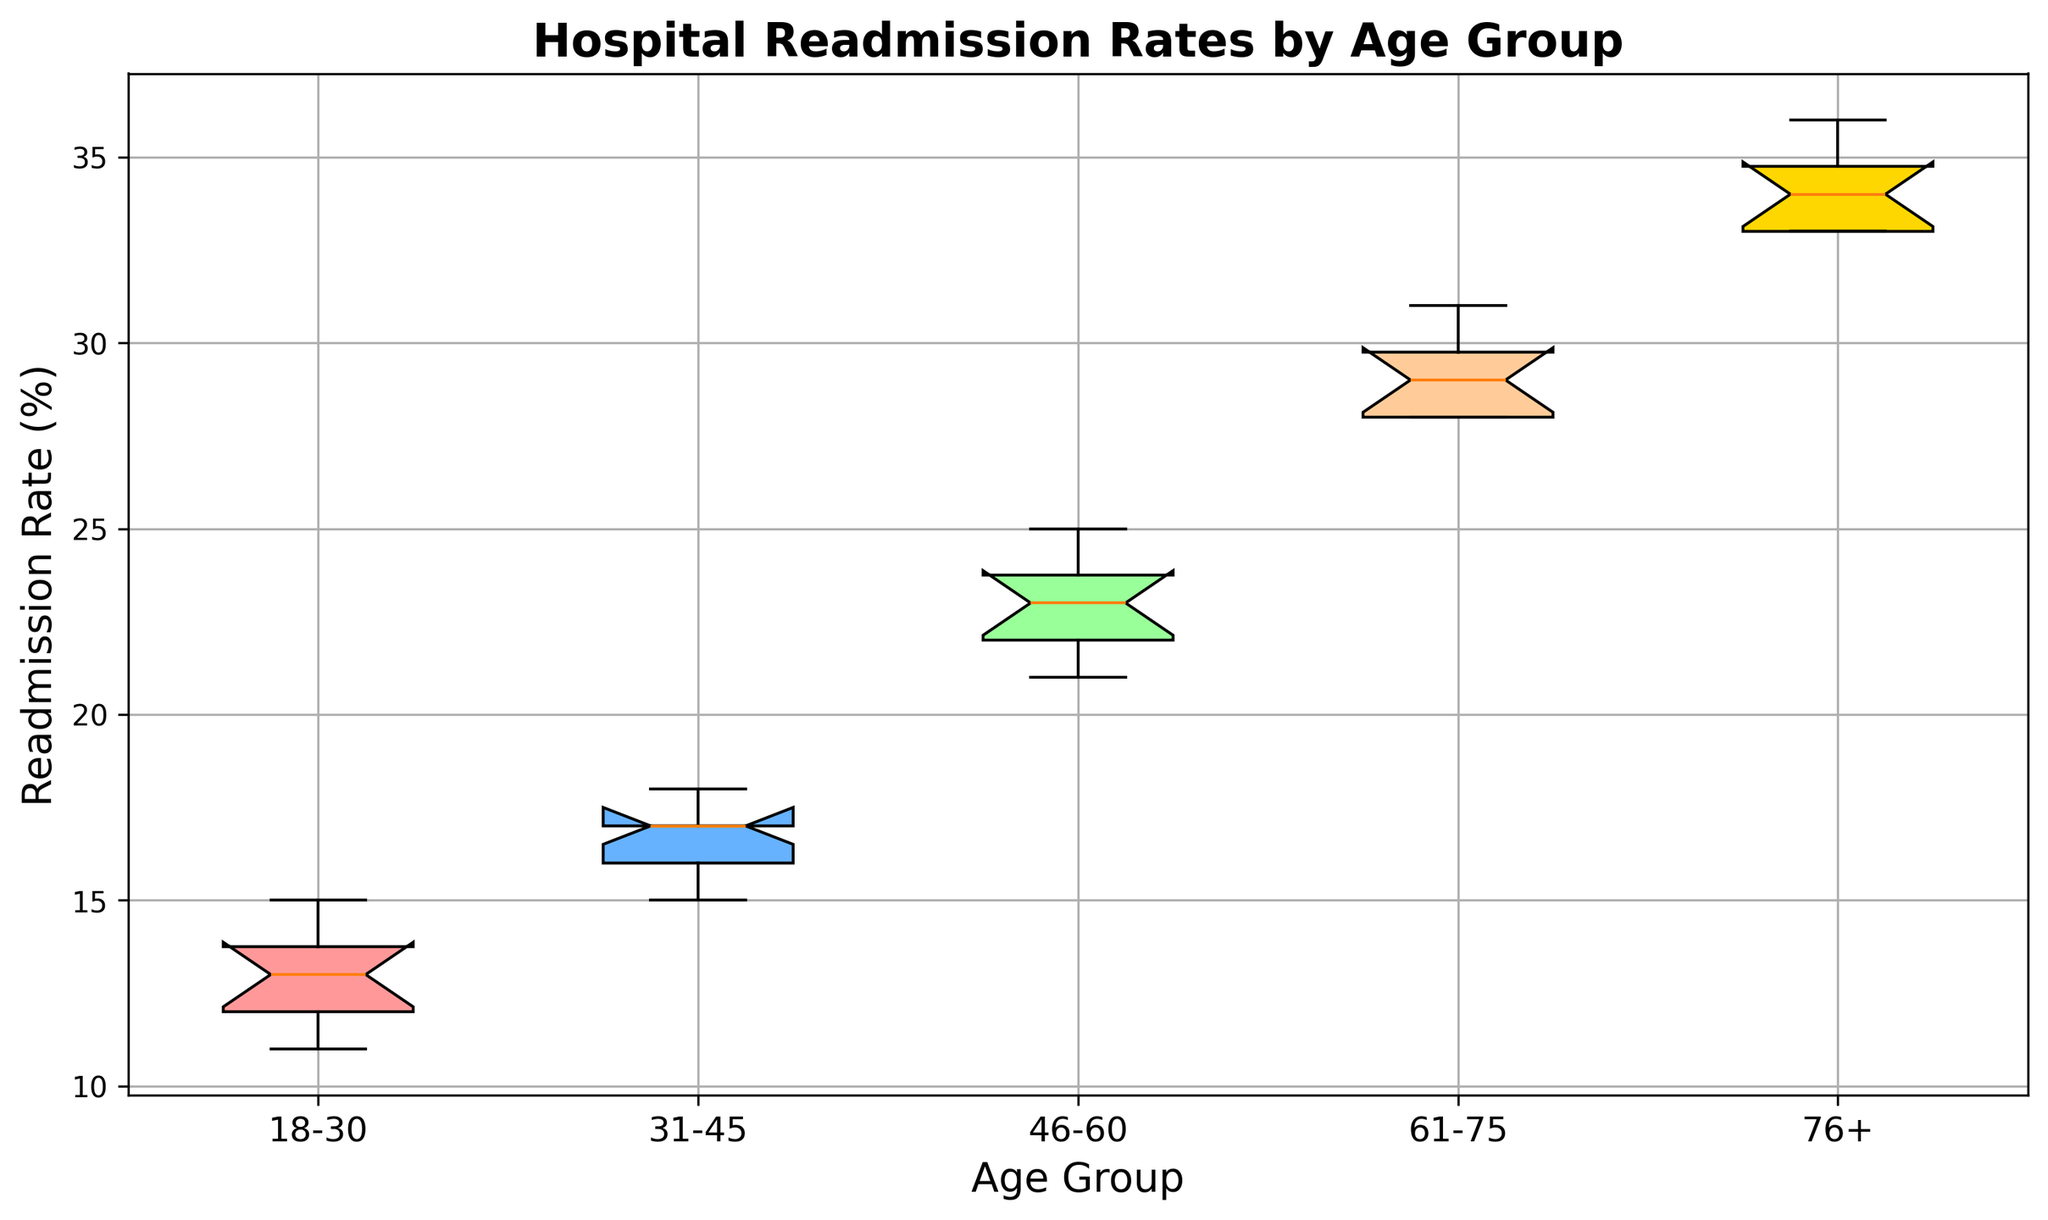What is the median readmission rate for the group aged 61-75? The median is the middle value when the data is sorted. For the 61-75 age group, the sorted values are 28, 28, 28, 28, 29, 29, 29, 29, 30, 30. There are 10 values in total and the median is the average of the 5th and 6th values, which is (29+29)/2 = 29.
Answer: 29 Which age group has the lowest median readmission rate? Look at the boxes of the box plot, where the median is represented by the horizontal line inside each box. The 18-30 age group has the lowest median readmission rate.
Answer: 18-30 What is the interquartile range (IQR) for the group aged 46-60? The IQR is the difference between the 75th percentile (upper quartile) and the 25th percentile (lower quartile). The 46-60 age group has values 21, 22, 22, 22, 23, 23, 23, 24, 24, 25. The 25th percentile (22) and the 75th percentile (24), so the IQR is 24 - 22 = 2.
Answer: 2 Which age group has the highest range of readmission rates? The range is the difference between the maximum and minimum values. Observe the whiskers of each box plot. The 76+ age group has the highest range, extending from 33 to 36, thus a range of 36 - 33 = 3.
Answer: 76+ How does the median readmission rate of age group 31-45 compare to age group 76+? Compare the median lines of both groups. The median of 31-45 is at 17, and the median of 76+ is at 34, showing that the age group 76+ has a significantly higher readmission median rate.
Answer: 76+ is much higher What is the difference in the median readmission rates between the youngest and oldest age groups? Identify the medians for 18-30 (which is 13) and 76+ (which is 34). The difference is 34 - 13 = 21.
Answer: 21 Which color represents the box plot for the 61-75 age group? Identify the color based on the order and mapping of age groups to colors. The 61-75 age group is the fourth age group listed and is represented by the color gold.
Answer: Gold Are there any outliers in the readmission rates for any age group? Outliers are typically indicated by points outside the whiskers. In this plot, there are no individual points outside the whiskers for any age group, indicating no outliers.
Answer: No Which age group shows the most variability in readmission rates? Variability is represented by the spread of the data within the whiskers. The 76+ age group shows the most variability, with a range from 33 to 36 and a wide box.
Answer: 76+ What is the median readmission rate for all age groups combined? To find the overall median, consider all data points together. Sorted: 11, 12, 12, 12, 13, 13, 13, 13, 14, 14, 15, 15, 16, 16, 16, 17, 17, 17, 17, 18, 18, 21, 22, 22, 22, 22, 23, 23, 23, 24, 24, 25, 28, 28, 28, 28, 29, 29, 29, 29, 30, 30, 33, 33, 33, 33, 34, 34, 34, 35, 35, 36. With 50 data points, the median is (29 + 29) / 2 = 29.
Answer: 29 